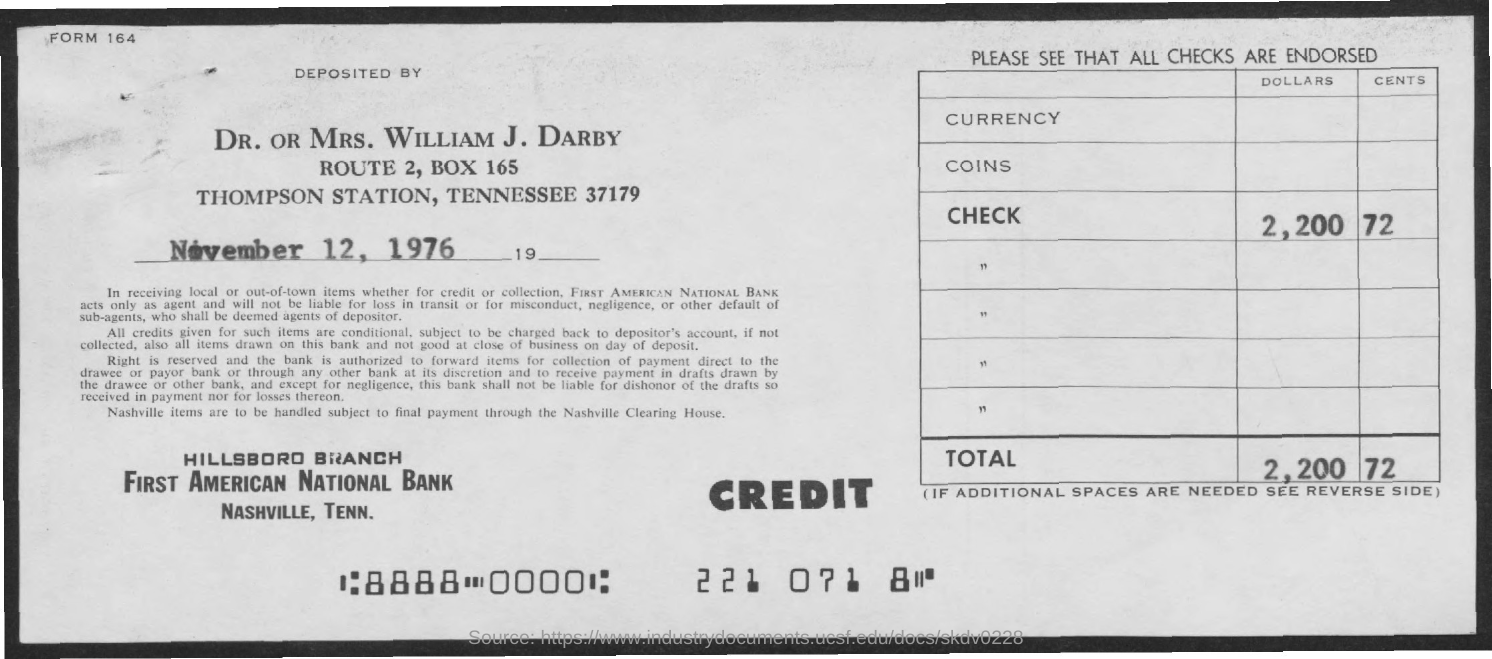What is the date mentioned in the given page ?
Provide a short and direct response. November 12, 1976. What is the amount of check in dollars mentioned ?
Provide a succinct answer. 2,200. What is the amount of check in cents mentioned ?
Your answer should be compact. 72. What is the name of the branch mentioned ?
Give a very brief answer. Hillsbord branch. What is the name of the bank mentioned ?
Give a very brief answer. FIRST AMERICAN NATIONAL BANK. What is the box no. mentioned ?
Keep it short and to the point. 165. What is the name of the station mentioned ?
Offer a very short reply. Thompson station. 